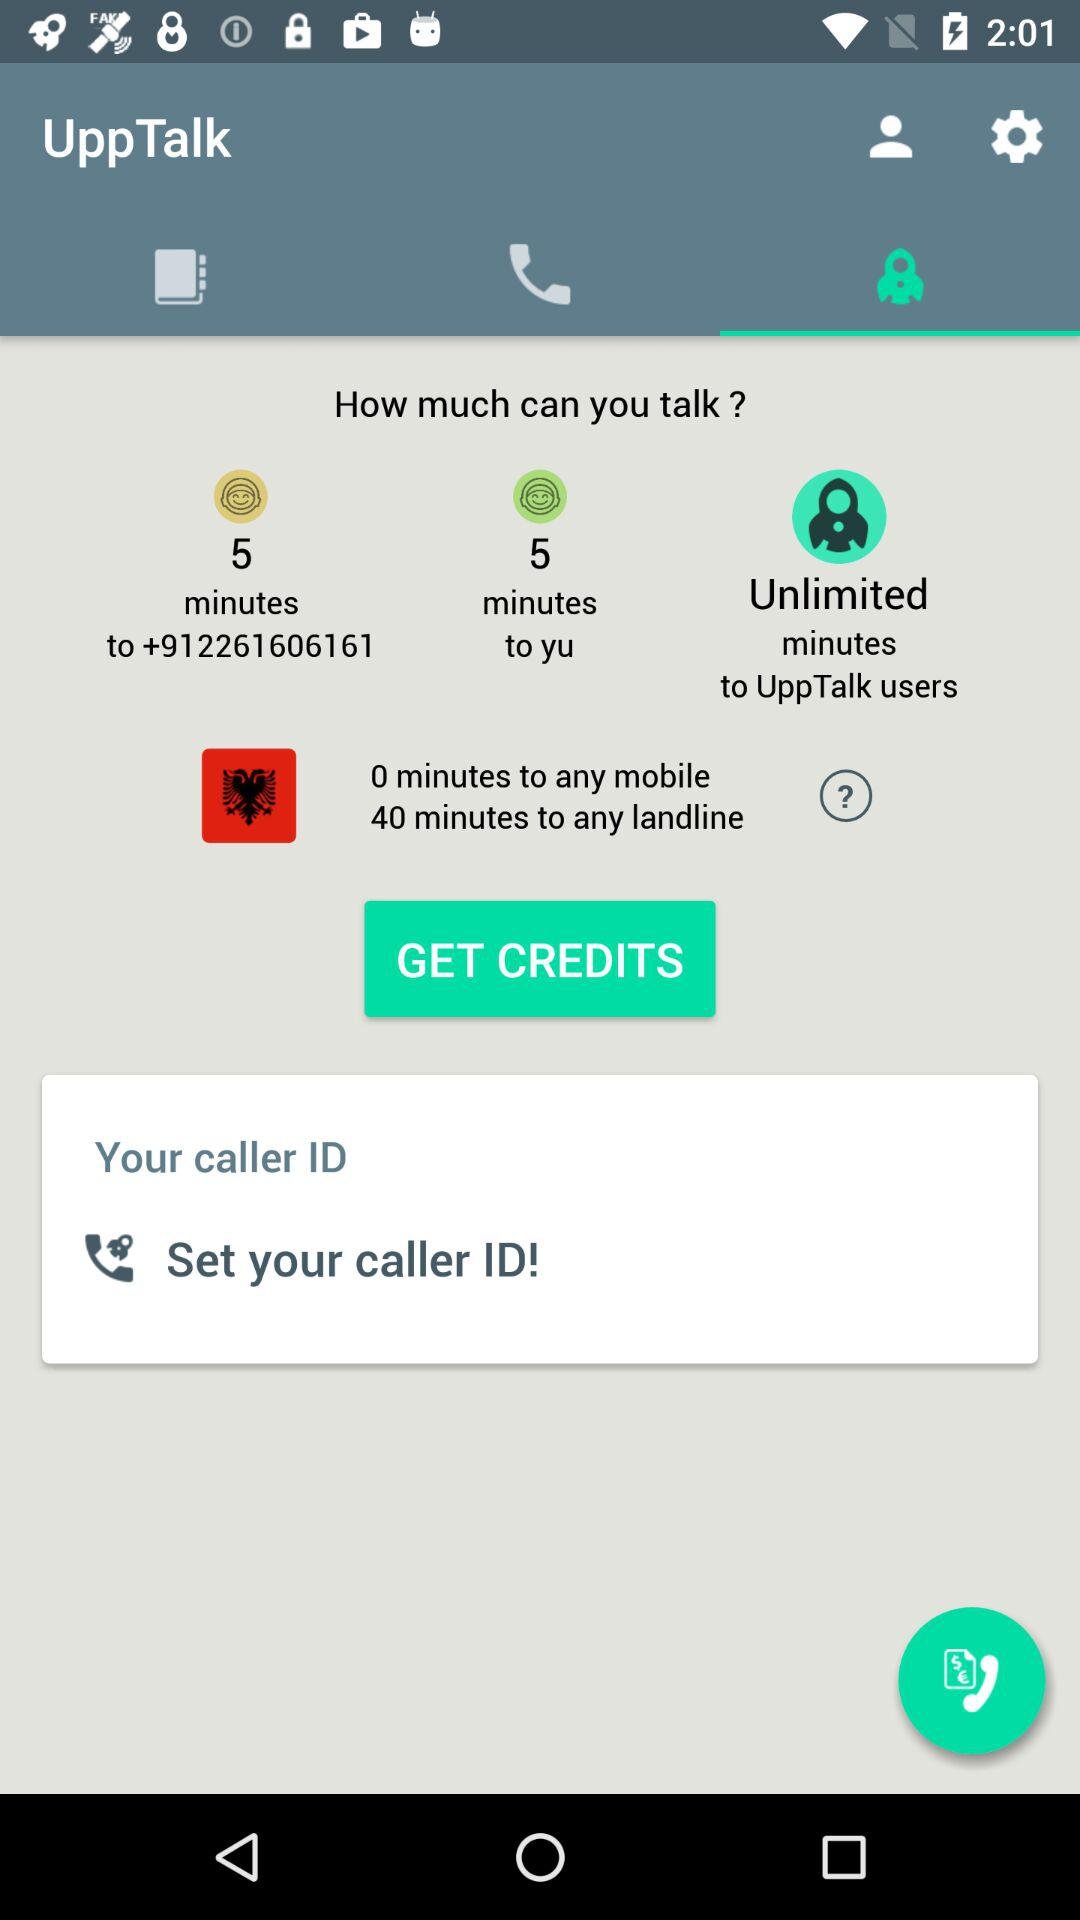What is the contact number? The contact number is +912261606161. 